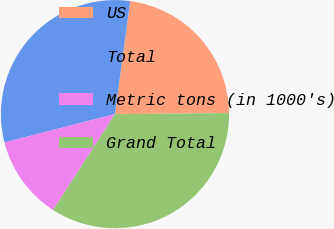Convert chart. <chart><loc_0><loc_0><loc_500><loc_500><pie_chart><fcel>US<fcel>Total<fcel>Metric tons (in 1000's)<fcel>Grand Total<nl><fcel>22.73%<fcel>31.12%<fcel>11.89%<fcel>34.27%<nl></chart> 